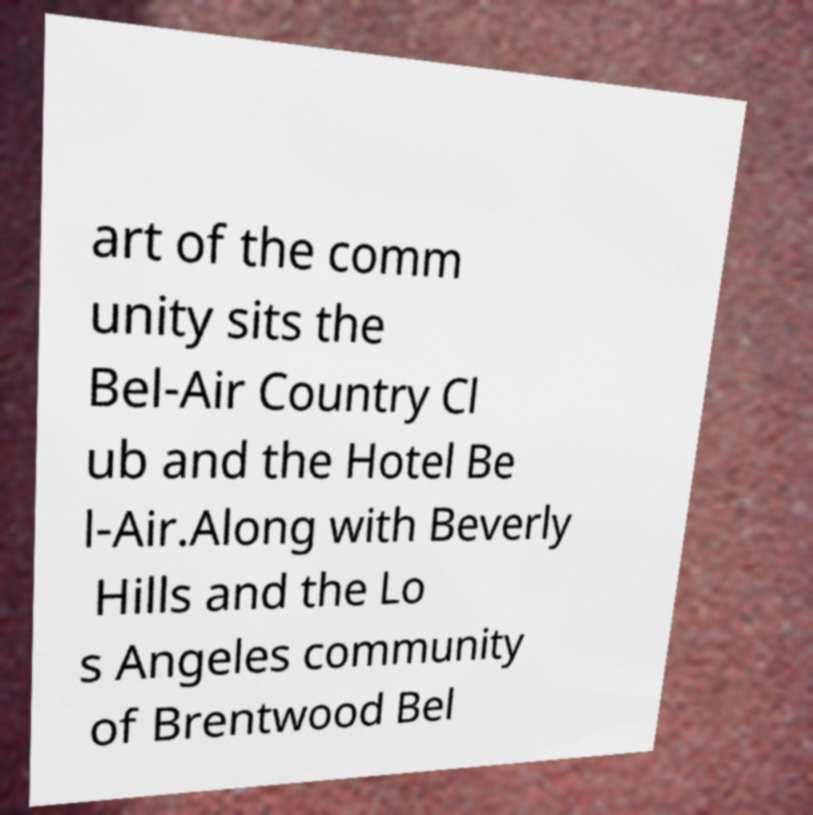Could you assist in decoding the text presented in this image and type it out clearly? art of the comm unity sits the Bel-Air Country Cl ub and the Hotel Be l-Air.Along with Beverly Hills and the Lo s Angeles community of Brentwood Bel 